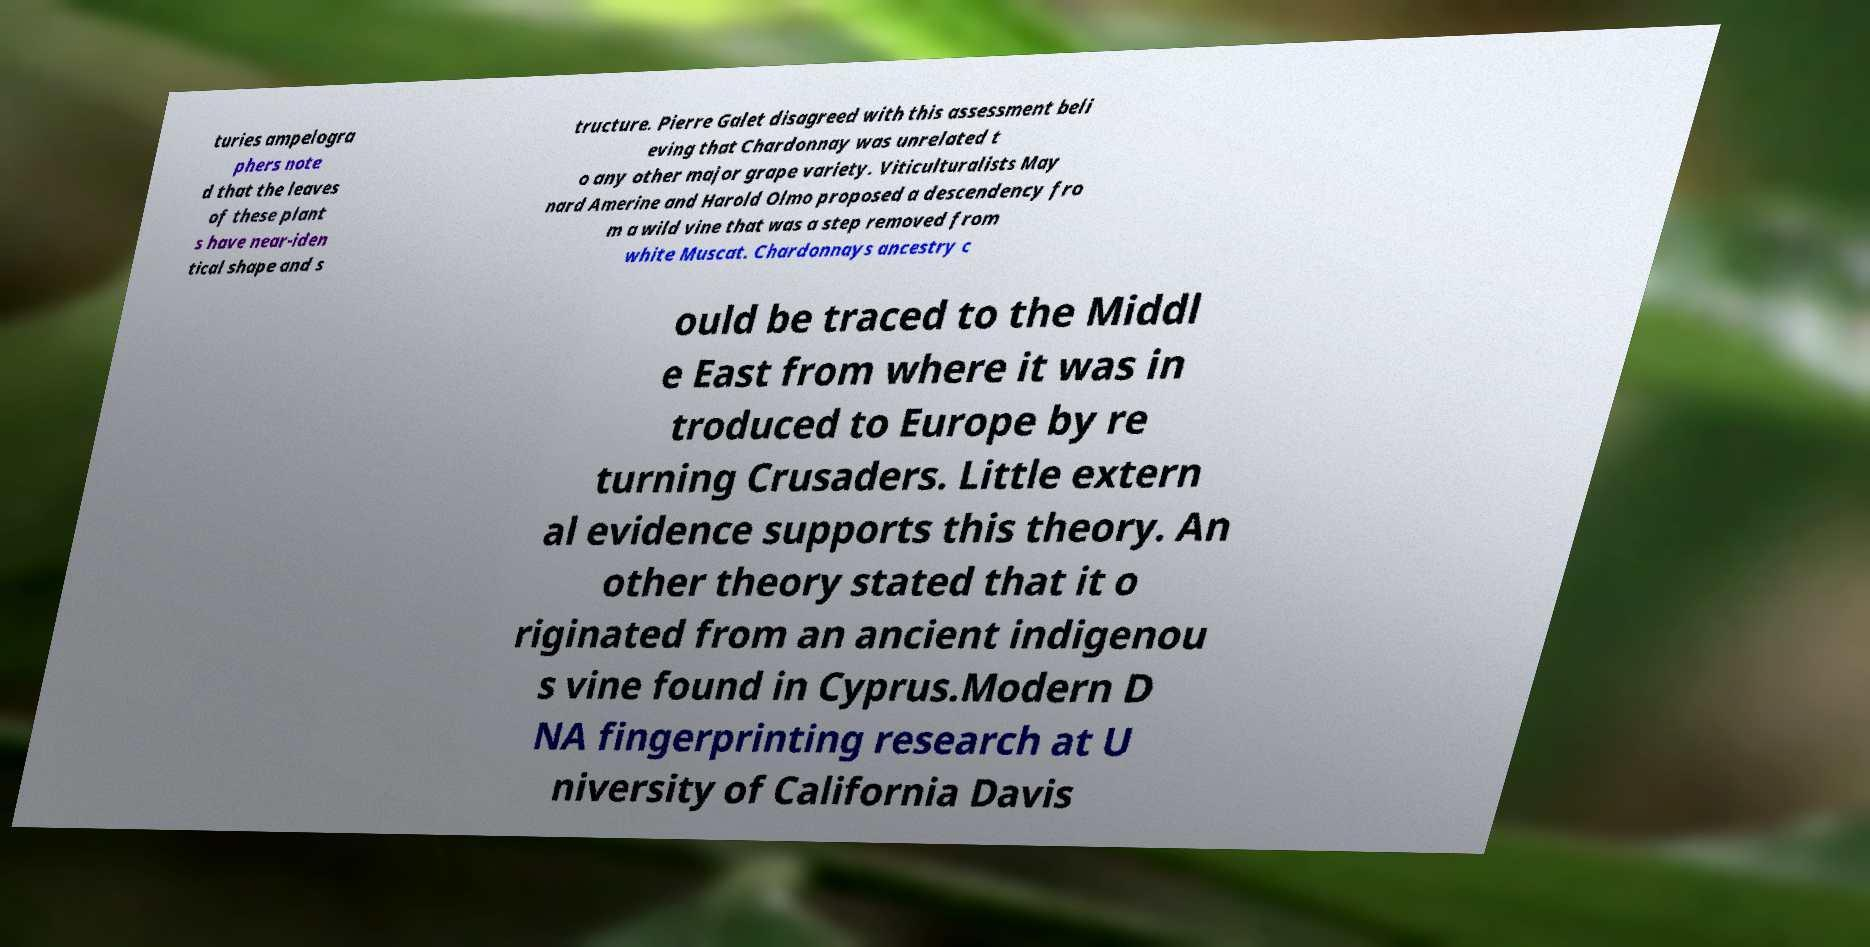Could you extract and type out the text from this image? turies ampelogra phers note d that the leaves of these plant s have near-iden tical shape and s tructure. Pierre Galet disagreed with this assessment beli eving that Chardonnay was unrelated t o any other major grape variety. Viticulturalists May nard Amerine and Harold Olmo proposed a descendency fro m a wild vine that was a step removed from white Muscat. Chardonnays ancestry c ould be traced to the Middl e East from where it was in troduced to Europe by re turning Crusaders. Little extern al evidence supports this theory. An other theory stated that it o riginated from an ancient indigenou s vine found in Cyprus.Modern D NA fingerprinting research at U niversity of California Davis 